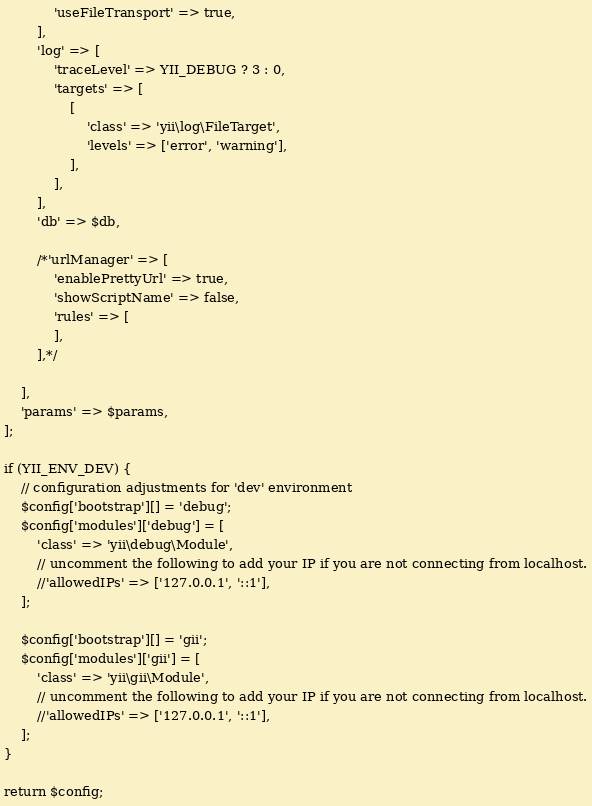Convert code to text. <code><loc_0><loc_0><loc_500><loc_500><_PHP_>            'useFileTransport' => true,
        ],
        'log' => [
            'traceLevel' => YII_DEBUG ? 3 : 0,
            'targets' => [
                [
                    'class' => 'yii\log\FileTarget',
                    'levels' => ['error', 'warning'],
                ],
            ],
        ],
        'db' => $db,
        
        /*'urlManager' => [
            'enablePrettyUrl' => true,
            'showScriptName' => false,
            'rules' => [
            ],
        ],*/
        
    ],
    'params' => $params,
];

if (YII_ENV_DEV) {
    // configuration adjustments for 'dev' environment
    $config['bootstrap'][] = 'debug';
    $config['modules']['debug'] = [
        'class' => 'yii\debug\Module',
        // uncomment the following to add your IP if you are not connecting from localhost.
        //'allowedIPs' => ['127.0.0.1', '::1'],
    ];

    $config['bootstrap'][] = 'gii';
    $config['modules']['gii'] = [
        'class' => 'yii\gii\Module',
        // uncomment the following to add your IP if you are not connecting from localhost.
        //'allowedIPs' => ['127.0.0.1', '::1'],
    ];
}

return $config;
</code> 